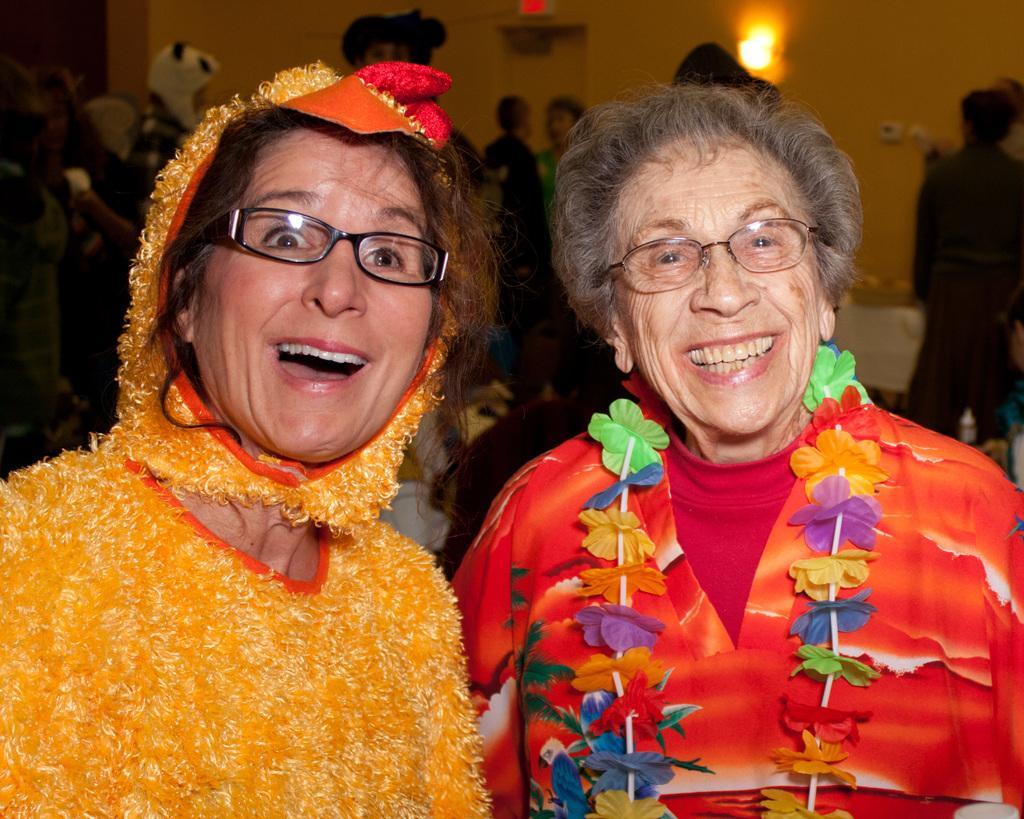Please provide a concise description of this image. In this image we can see two women wearing the glasses and smiling. We can also see the woman on the right wearing the garland. In the background, we can see a few people standing. We can also see the wall and also lights. 